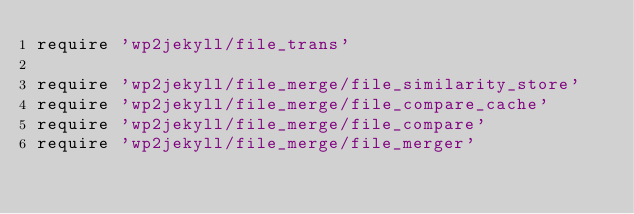Convert code to text. <code><loc_0><loc_0><loc_500><loc_500><_Ruby_>require 'wp2jekyll/file_trans'

require 'wp2jekyll/file_merge/file_similarity_store'
require 'wp2jekyll/file_merge/file_compare_cache'
require 'wp2jekyll/file_merge/file_compare'
require 'wp2jekyll/file_merge/file_merger'
</code> 